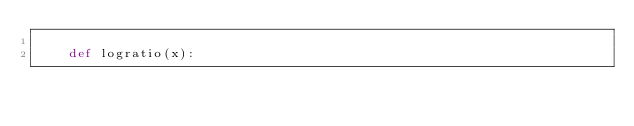<code> <loc_0><loc_0><loc_500><loc_500><_Python_>    
    def logratio(x):</code> 